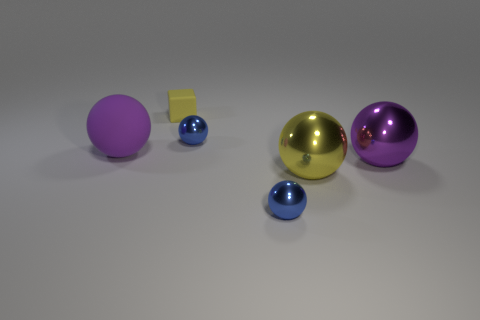Subtract all big purple shiny balls. How many balls are left? 4 Subtract all yellow balls. How many balls are left? 4 Subtract 2 spheres. How many spheres are left? 3 Add 2 tiny rubber blocks. How many objects exist? 8 Subtract all red balls. Subtract all blue cylinders. How many balls are left? 5 Subtract all balls. How many objects are left? 1 Subtract 0 purple blocks. How many objects are left? 6 Subtract all tiny shiny spheres. Subtract all yellow cubes. How many objects are left? 3 Add 4 tiny blue metallic balls. How many tiny blue metallic balls are left? 6 Add 2 big red rubber spheres. How many big red rubber spheres exist? 2 